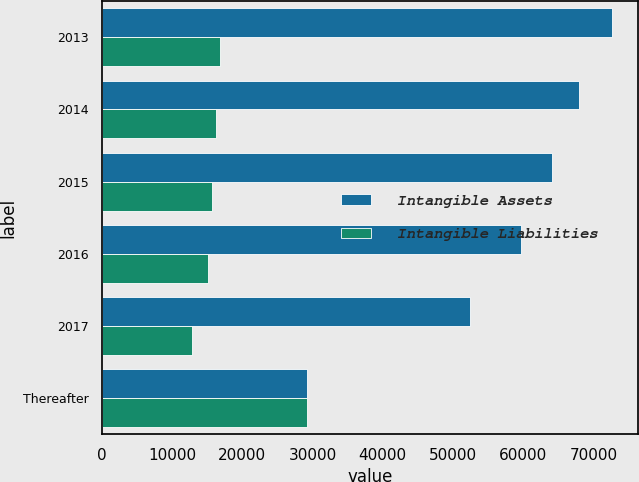Convert chart to OTSL. <chart><loc_0><loc_0><loc_500><loc_500><stacked_bar_chart><ecel><fcel>2013<fcel>2014<fcel>2015<fcel>2016<fcel>2017<fcel>Thereafter<nl><fcel>Intangible Assets<fcel>72684<fcel>67943<fcel>64078<fcel>59674<fcel>52452<fcel>29243<nl><fcel>Intangible Liabilities<fcel>16772<fcel>16261<fcel>15696<fcel>15150<fcel>12787<fcel>29243<nl></chart> 